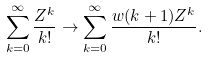<formula> <loc_0><loc_0><loc_500><loc_500>\sum _ { k = 0 } ^ { \infty } \frac { Z ^ { k } } { k ! } \rightarrow \sum _ { k = 0 } ^ { \infty } \frac { w ( k + 1 ) Z ^ { k } } { k ! } .</formula> 